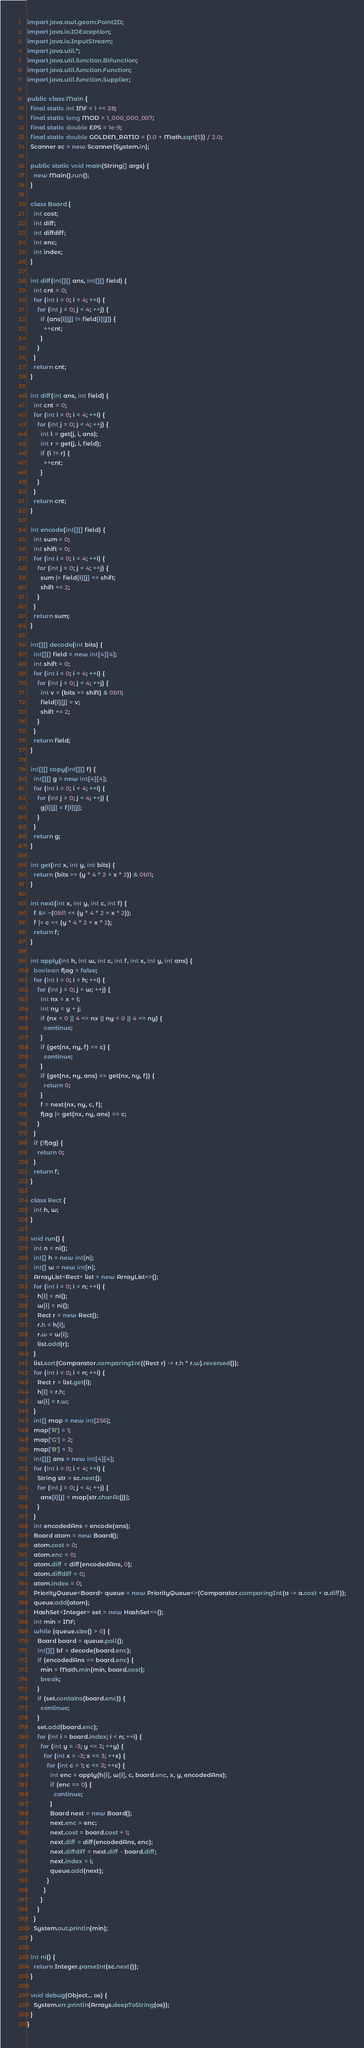Convert code to text. <code><loc_0><loc_0><loc_500><loc_500><_Java_>import java.awt.geom.Point2D;
import java.io.IOException;
import java.io.InputStream;
import java.util.*;
import java.util.function.BiFunction;
import java.util.function.Function;
import java.util.function.Supplier;

public class Main {
  final static int INF = 1 << 28;
  final static long MOD = 1_000_000_007;
  final static double EPS = 1e-9;
  final static double GOLDEN_RATIO = (1.0 + Math.sqrt(5)) / 2.0;
  Scanner sc = new Scanner(System.in);

  public static void main(String[] args) {
    new Main().run();
  }

  class Board {
    int cost;
    int diff;
    int diffdiff;
    int enc;
    int index;
  }

  int diff(int[][] ans, int[][] field) {
    int cnt = 0;
    for (int i = 0; i < 4; ++i) {
      for (int j = 0; j < 4; ++j) {
        if (ans[i][j] != field[i][j]) {
          ++cnt;
        }
      }
    }
    return cnt;
  }

  int diff(int ans, int field) {
    int cnt = 0;
    for (int i = 0; i < 4; ++i) {
      for (int j = 0; j < 4; ++j) {
        int l = get(j, i, ans);
        int r = get(j, i, field);
        if (l != r) {
          ++cnt;
        }
      }
    }
    return cnt;
  }

  int encode(int[][] field) {
    int sum = 0;
    int shift = 0;
    for (int i = 0; i < 4; ++i) {
      for (int j = 0; j < 4; ++j) {
        sum |= field[i][j] << shift;
        shift += 2;
      }
    }
    return sum;
  }

  int[][] decode(int bits) {
    int[][] field = new int[4][4];
    int shift = 0;
    for (int i = 0; i < 4; ++i) {
      for (int j = 0; j < 4; ++j) {
        int v = (bits >> shift) & 0b11;
        field[i][j] = v;
        shift += 2;
      }
    }
    return field;
  }

  int[][] copy(int[][] f) {
    int[][] g = new int[4][4];
    for (int i = 0; i < 4; ++i) {
      for (int j = 0; j < 4; ++j) {
        g[i][j] = f[i][j];
      }
    }
    return g;
  }

  int get(int x, int y, int bits) {
    return (bits >> (y * 4 * 2 + x * 2)) & 0b11;
  }

  int next(int x, int y, int c, int f) {
    f &= ~(0b11 << (y * 4 * 2 + x * 2));
    f |= c << (y * 4 * 2 + x * 2);
    return f;
  }

  int apply(int h, int w, int c, int f, int x, int y, int ans) {
    boolean flag = false;
    for (int i = 0; i < h; ++i) {
      for (int j = 0; j < w; ++j) {
        int nx = x + i;
        int ny = y + j;
        if (nx < 0 || 4 <= nx || ny < 0 || 4 <= ny) {
          continue;
        }
        if (get(nx, ny, f) == c) {
          continue;
        }
        if (get(nx, ny, ans) == get(nx, ny, f)) {
          return 0;
        }
        f = next(nx, ny, c, f);
        flag |= get(nx, ny, ans) == c;
      }
    }
    if (!flag) {
      return 0;
    }
    return f;
  }

  class Rect {
    int h, w;
  }

  void run() {
    int n = ni();
    int[] h = new int[n];
    int[] w = new int[n];
    ArrayList<Rect> list = new ArrayList<>();
    for (int i = 0; i < n; ++i) {
      h[i] = ni();
      w[i] = ni();
      Rect r = new Rect();
      r.h = h[i];
      r.w = w[i];
      list.add(r);
    }
    list.sort(Comparator.comparingInt((Rect r) -> r.h * r.w).reversed());
    for (int i = 0; i < n; ++i) {
      Rect r = list.get(i);
      h[i] = r.h;
      w[i] = r.w;
    }
    int[] map = new int[256];
    map['R'] = 1;
    map['G'] = 2;
    map['B'] = 3;
    int[][] ans = new int[4][4];
    for (int i = 0; i < 4; ++i) {
      String str = sc.next();
      for (int j = 0; j < 4; ++j) {
        ans[i][j] = map[str.charAt(j)];
      }
    }
    int encodedAns = encode(ans);
    Board atom = new Board();
    atom.cost = 0;
    atom.enc = 0;
    atom.diff = diff(encodedAns, 0);
    atom.diffdiff = 0;
    atom.index = 0;
    PriorityQueue<Board> queue = new PriorityQueue<>(Comparator.comparingInt(a -> a.cost + a.diff));
    queue.add(atom);
    HashSet<Integer> set = new HashSet<>();
    int min = INF;
    while (queue.size() > 0) {
      Board board = queue.poll();
      int[][] bf = decode(board.enc);
      if (encodedAns == board.enc) {
        min = Math.min(min, board.cost);
        break;
      }
      if (set.contains(board.enc)) {
        continue;
      }
      set.add(board.enc);
      for (int i = board.index; i < n; ++i) {
        for (int y = -3; y <= 3; ++y) {
          for (int x = -3; x <= 3; ++x) {
            for (int c = 1; c <= 3; ++c) {
              int enc = apply(h[i], w[i], c, board.enc, x, y, encodedAns);
              if (enc == 0) {
                continue;
              }
              Board next = new Board();
              next.enc = enc;
              next.cost = board.cost + 1;
              next.diff = diff(encodedAns, enc);
              next.diffdiff = next.diff - board.diff;
              next.index = i;
              queue.add(next);
            }
          }
        }
      }
    }
    System.out.println(min);
  }

  int ni() {
    return Integer.parseInt(sc.next());
  }

  void debug(Object... os) {
    System.err.println(Arrays.deepToString(os));
  }
}</code> 